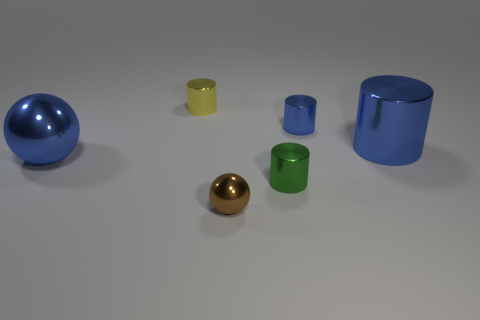Is the brown metallic sphere the same size as the blue metal ball?
Your response must be concise. No. How many cylinders are tiny blue objects or green things?
Provide a succinct answer. 2. What is the material of the small object that is the same color as the big metal cylinder?
Your answer should be very brief. Metal. What number of blue shiny objects have the same shape as the green thing?
Ensure brevity in your answer.  2. Is the number of small blue shiny things that are left of the small blue metal cylinder greater than the number of large blue metallic cylinders to the right of the big ball?
Your answer should be compact. No. Does the sphere right of the small yellow shiny object have the same color as the large cylinder?
Your answer should be very brief. No. What is the size of the blue sphere?
Your answer should be compact. Large. There is a green object that is the same size as the yellow cylinder; what is it made of?
Your response must be concise. Metal. What is the color of the small thing that is to the right of the green shiny cylinder?
Offer a very short reply. Blue. How many tiny spheres are there?
Your response must be concise. 1. 